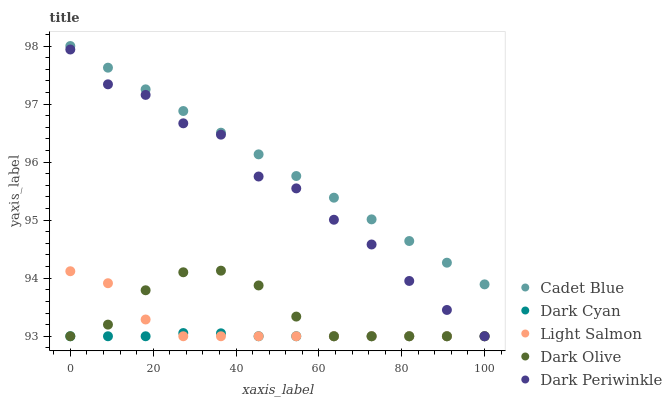Does Dark Cyan have the minimum area under the curve?
Answer yes or no. Yes. Does Cadet Blue have the maximum area under the curve?
Answer yes or no. Yes. Does Light Salmon have the minimum area under the curve?
Answer yes or no. No. Does Light Salmon have the maximum area under the curve?
Answer yes or no. No. Is Cadet Blue the smoothest?
Answer yes or no. Yes. Is Dark Periwinkle the roughest?
Answer yes or no. Yes. Is Light Salmon the smoothest?
Answer yes or no. No. Is Light Salmon the roughest?
Answer yes or no. No. Does Dark Cyan have the lowest value?
Answer yes or no. Yes. Does Cadet Blue have the lowest value?
Answer yes or no. No. Does Cadet Blue have the highest value?
Answer yes or no. Yes. Does Light Salmon have the highest value?
Answer yes or no. No. Is Dark Cyan less than Cadet Blue?
Answer yes or no. Yes. Is Cadet Blue greater than Dark Olive?
Answer yes or no. Yes. Does Light Salmon intersect Dark Periwinkle?
Answer yes or no. Yes. Is Light Salmon less than Dark Periwinkle?
Answer yes or no. No. Is Light Salmon greater than Dark Periwinkle?
Answer yes or no. No. Does Dark Cyan intersect Cadet Blue?
Answer yes or no. No. 